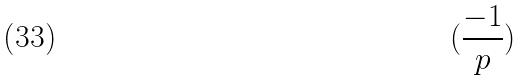Convert formula to latex. <formula><loc_0><loc_0><loc_500><loc_500>( \frac { - 1 } { p } )</formula> 